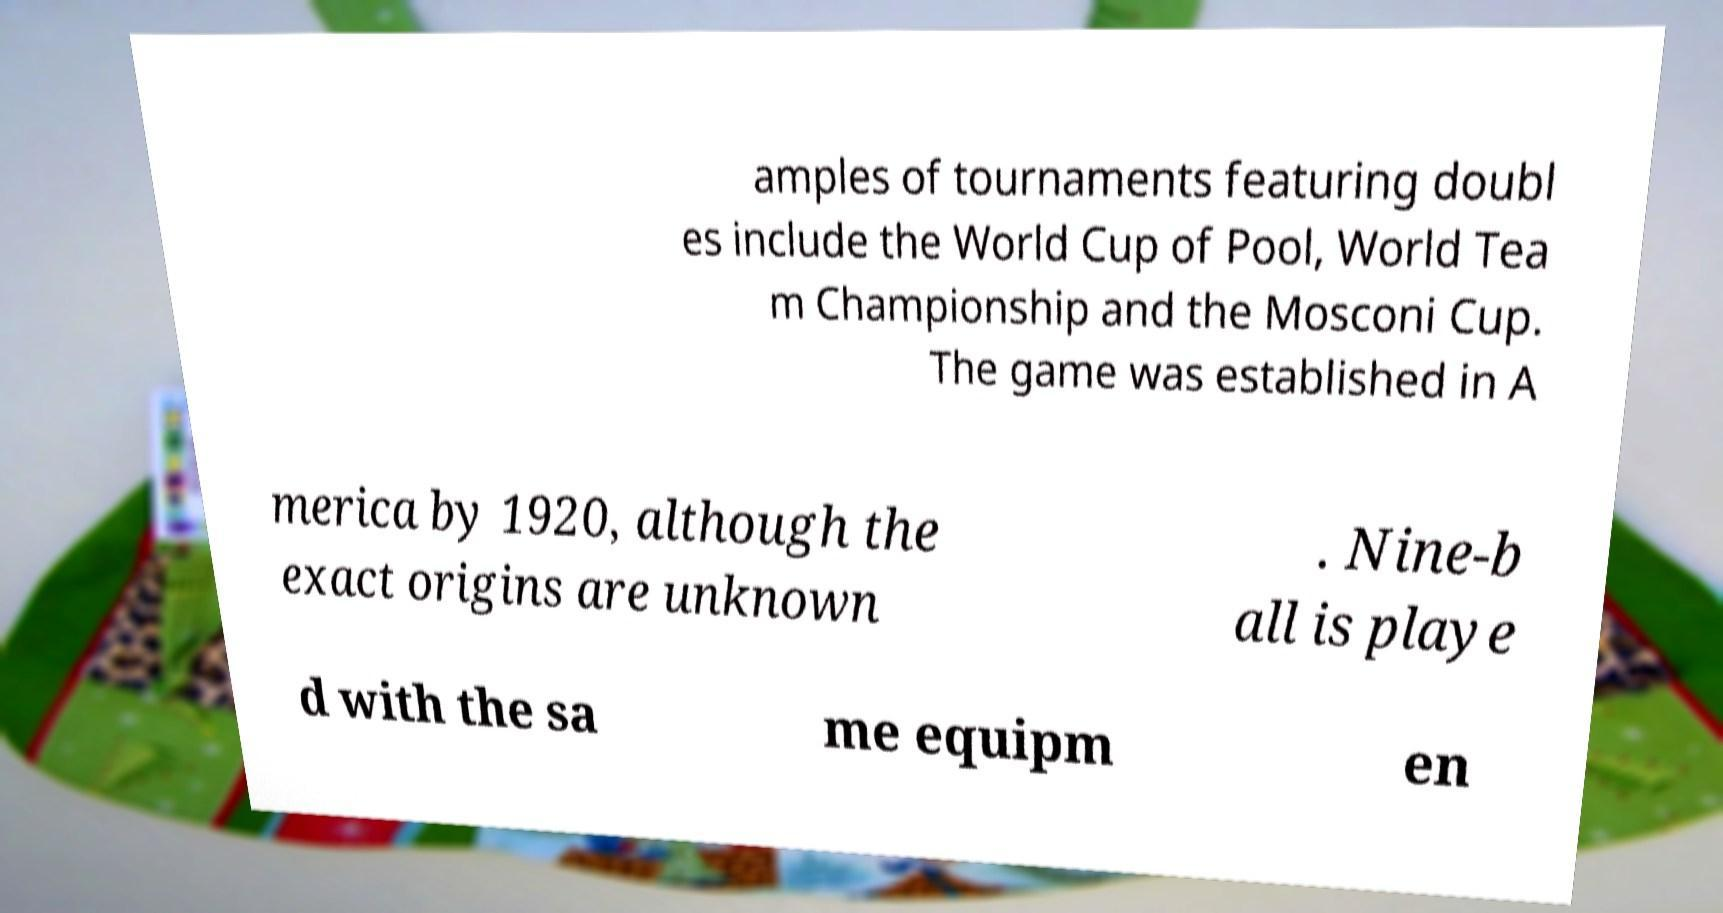Please identify and transcribe the text found in this image. amples of tournaments featuring doubl es include the World Cup of Pool, World Tea m Championship and the Mosconi Cup. The game was established in A merica by 1920, although the exact origins are unknown . Nine-b all is playe d with the sa me equipm en 